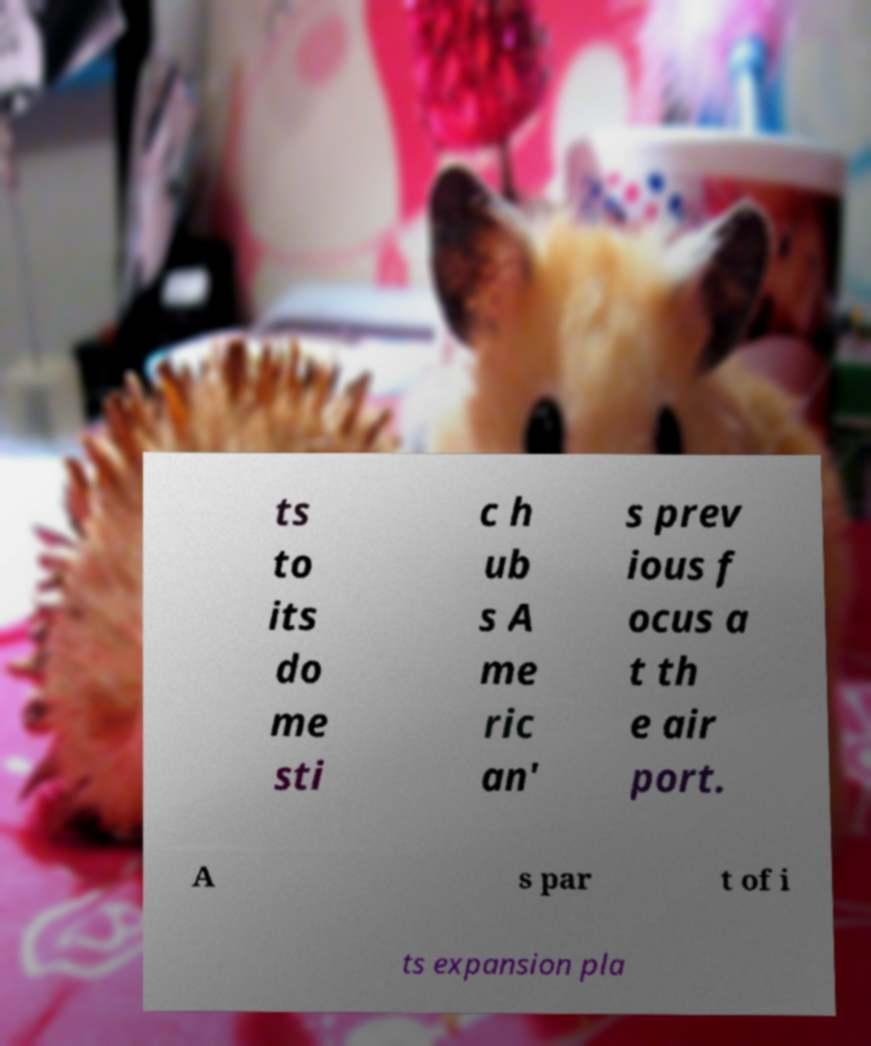Can you accurately transcribe the text from the provided image for me? ts to its do me sti c h ub s A me ric an' s prev ious f ocus a t th e air port. A s par t of i ts expansion pla 